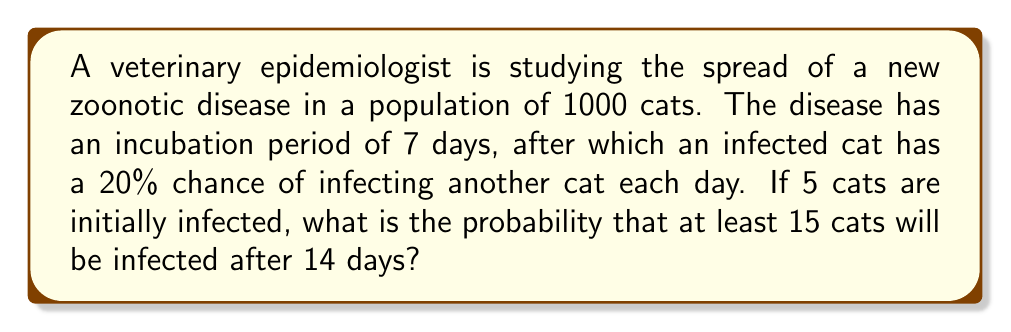Show me your answer to this math problem. Let's approach this step-by-step:

1) First, we need to calculate the expected number of new infections per initially infected cat over the 7-day period after the incubation:

   $$ E(\text{new infections per cat}) = 7 \times 0.20 = 1.4 $$

2) This scenario follows a branching process. The total number of infected cats after 14 days (including the initial 5) can be modeled as a Galton-Watson process with a Poisson distribution:

   $$ X \sim \text{Poisson}(5 \times 1.4) = \text{Poisson}(7) $$

3) We want to find $P(X \geq 15)$. It's often easier to calculate $P(X < 15)$ and then subtract from 1:

   $$ P(X \geq 15) = 1 - P(X < 15) = 1 - P(X \leq 14) $$

4) The cumulative distribution function of a Poisson distribution is related to the gamma function:

   $$ P(X \leq k) = \frac{\Gamma(k+1, \lambda)}{\Gamma(k+1)} $$

   Where $\Gamma(a,x)$ is the upper incomplete gamma function and $\Gamma(a)$ is the gamma function.

5) In our case:

   $$ P(X < 15) = P(X \leq 14) = \frac{\Gamma(15, 7)}{\Gamma(15)} $$

6) Using a statistical software or calculator to evaluate this:

   $$ P(X < 15) \approx 0.9898 $$

7) Therefore:

   $$ P(X \geq 15) = 1 - 0.9898 \approx 0.0102 $$
Answer: $0.0102$ or $1.02\%$ 